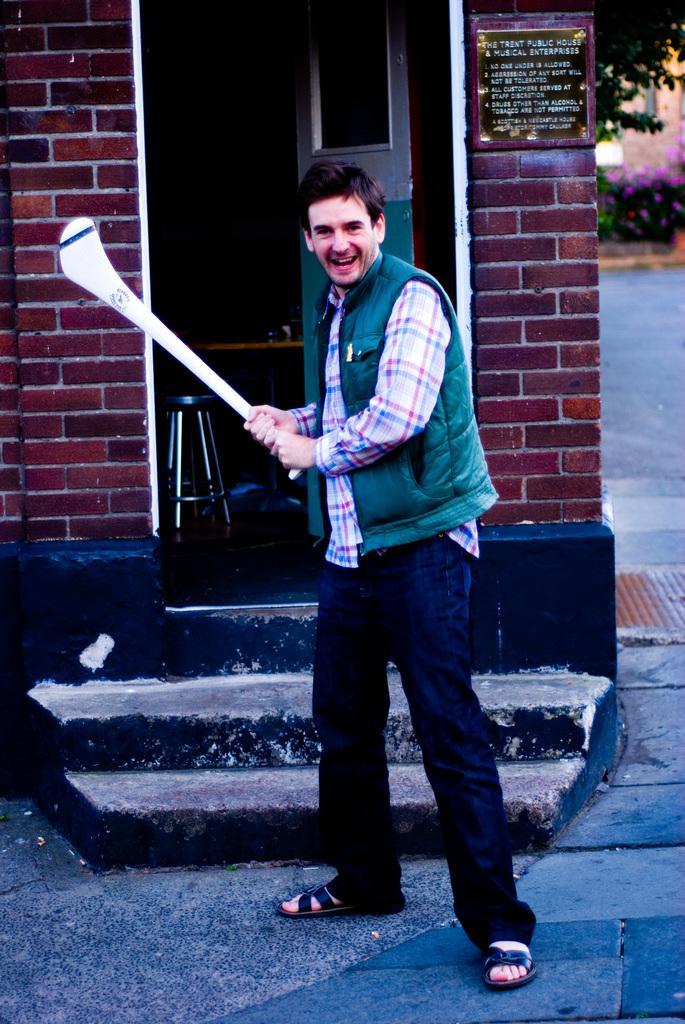Could you give a brief overview of what you see in this image? In this image we can see this person wearing green sweater is holding a bat in his hands and standing on the road. In the background, we can see stairs, brick wall and trees here. 